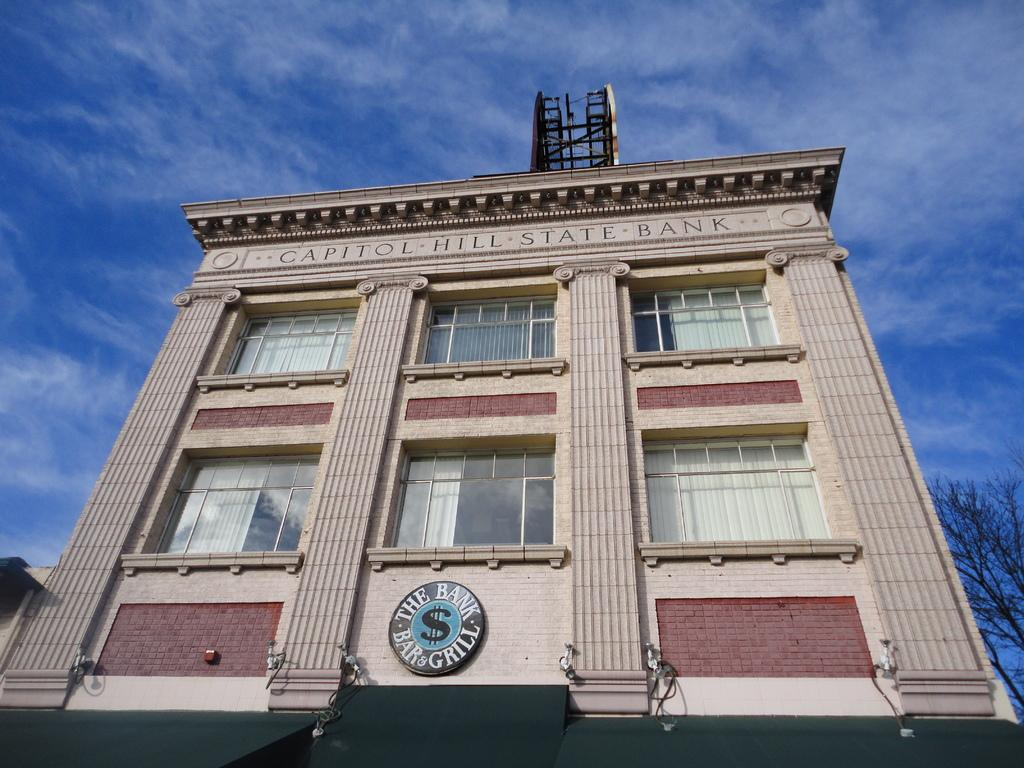What type of building is depicted in the image? There is a building of a bank in the image. Are there any other objects or structures near the bank building? Yes, there is a tree beside the building in the image. What type of wool is being spun by the people in the image? There are no people or wool present in the image; it only features a bank building and a tree. 